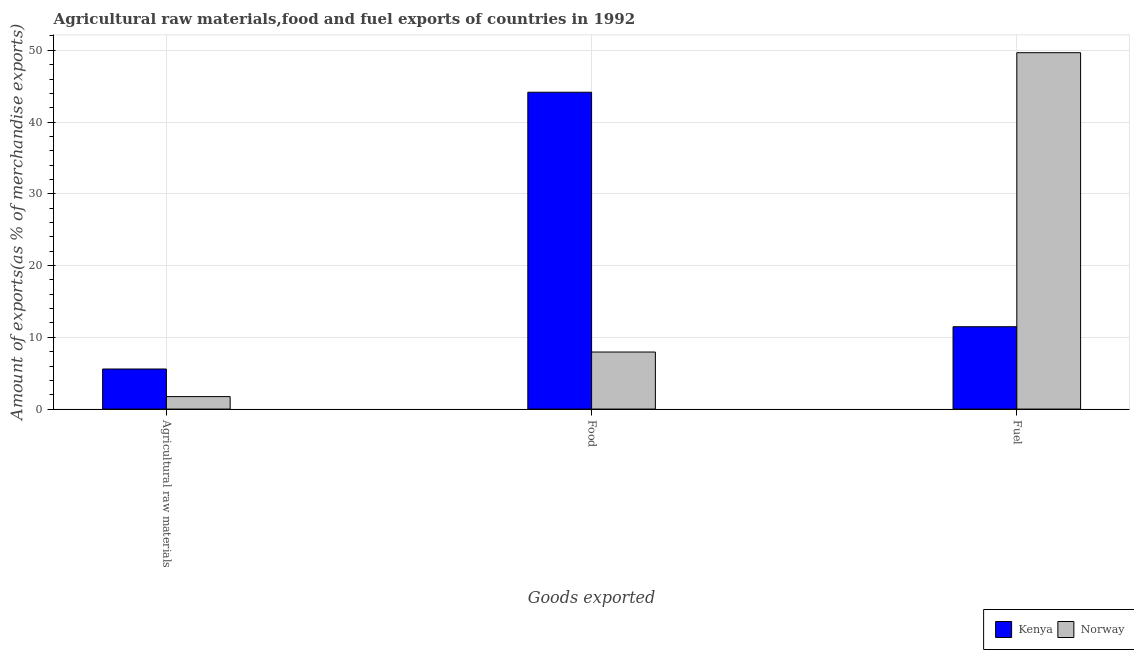How many different coloured bars are there?
Give a very brief answer. 2. How many groups of bars are there?
Make the answer very short. 3. Are the number of bars per tick equal to the number of legend labels?
Your answer should be very brief. Yes. What is the label of the 2nd group of bars from the left?
Make the answer very short. Food. What is the percentage of fuel exports in Norway?
Your answer should be very brief. 49.67. Across all countries, what is the maximum percentage of fuel exports?
Offer a terse response. 49.67. Across all countries, what is the minimum percentage of fuel exports?
Keep it short and to the point. 11.48. In which country was the percentage of food exports maximum?
Provide a short and direct response. Kenya. In which country was the percentage of fuel exports minimum?
Make the answer very short. Kenya. What is the total percentage of raw materials exports in the graph?
Offer a terse response. 7.32. What is the difference between the percentage of food exports in Norway and that in Kenya?
Offer a very short reply. -36.2. What is the difference between the percentage of fuel exports in Norway and the percentage of food exports in Kenya?
Keep it short and to the point. 5.51. What is the average percentage of raw materials exports per country?
Your answer should be very brief. 3.66. What is the difference between the percentage of food exports and percentage of fuel exports in Kenya?
Your response must be concise. 32.68. In how many countries, is the percentage of fuel exports greater than 38 %?
Keep it short and to the point. 1. What is the ratio of the percentage of food exports in Norway to that in Kenya?
Offer a terse response. 0.18. Is the difference between the percentage of fuel exports in Kenya and Norway greater than the difference between the percentage of food exports in Kenya and Norway?
Provide a succinct answer. No. What is the difference between the highest and the second highest percentage of raw materials exports?
Offer a terse response. 3.85. What is the difference between the highest and the lowest percentage of raw materials exports?
Give a very brief answer. 3.85. In how many countries, is the percentage of raw materials exports greater than the average percentage of raw materials exports taken over all countries?
Your answer should be compact. 1. Is the sum of the percentage of fuel exports in Norway and Kenya greater than the maximum percentage of food exports across all countries?
Offer a terse response. Yes. What does the 2nd bar from the right in Agricultural raw materials represents?
Your answer should be very brief. Kenya. Is it the case that in every country, the sum of the percentage of raw materials exports and percentage of food exports is greater than the percentage of fuel exports?
Make the answer very short. No. Are all the bars in the graph horizontal?
Keep it short and to the point. No. Are the values on the major ticks of Y-axis written in scientific E-notation?
Your answer should be compact. No. Does the graph contain any zero values?
Offer a very short reply. No. How are the legend labels stacked?
Your answer should be very brief. Horizontal. What is the title of the graph?
Offer a terse response. Agricultural raw materials,food and fuel exports of countries in 1992. Does "Korea (Democratic)" appear as one of the legend labels in the graph?
Provide a succinct answer. No. What is the label or title of the X-axis?
Keep it short and to the point. Goods exported. What is the label or title of the Y-axis?
Your answer should be very brief. Amount of exports(as % of merchandise exports). What is the Amount of exports(as % of merchandise exports) in Kenya in Agricultural raw materials?
Offer a very short reply. 5.59. What is the Amount of exports(as % of merchandise exports) in Norway in Agricultural raw materials?
Offer a very short reply. 1.74. What is the Amount of exports(as % of merchandise exports) in Kenya in Food?
Provide a short and direct response. 44.16. What is the Amount of exports(as % of merchandise exports) of Norway in Food?
Your answer should be very brief. 7.95. What is the Amount of exports(as % of merchandise exports) in Kenya in Fuel?
Your answer should be very brief. 11.48. What is the Amount of exports(as % of merchandise exports) in Norway in Fuel?
Your answer should be compact. 49.67. Across all Goods exported, what is the maximum Amount of exports(as % of merchandise exports) in Kenya?
Make the answer very short. 44.16. Across all Goods exported, what is the maximum Amount of exports(as % of merchandise exports) in Norway?
Provide a short and direct response. 49.67. Across all Goods exported, what is the minimum Amount of exports(as % of merchandise exports) in Kenya?
Ensure brevity in your answer.  5.59. Across all Goods exported, what is the minimum Amount of exports(as % of merchandise exports) of Norway?
Your answer should be very brief. 1.74. What is the total Amount of exports(as % of merchandise exports) in Kenya in the graph?
Keep it short and to the point. 61.22. What is the total Amount of exports(as % of merchandise exports) in Norway in the graph?
Give a very brief answer. 59.36. What is the difference between the Amount of exports(as % of merchandise exports) in Kenya in Agricultural raw materials and that in Food?
Provide a succinct answer. -38.57. What is the difference between the Amount of exports(as % of merchandise exports) in Norway in Agricultural raw materials and that in Food?
Your response must be concise. -6.21. What is the difference between the Amount of exports(as % of merchandise exports) in Kenya in Agricultural raw materials and that in Fuel?
Offer a terse response. -5.89. What is the difference between the Amount of exports(as % of merchandise exports) in Norway in Agricultural raw materials and that in Fuel?
Make the answer very short. -47.93. What is the difference between the Amount of exports(as % of merchandise exports) in Kenya in Food and that in Fuel?
Ensure brevity in your answer.  32.68. What is the difference between the Amount of exports(as % of merchandise exports) of Norway in Food and that in Fuel?
Offer a terse response. -41.72. What is the difference between the Amount of exports(as % of merchandise exports) of Kenya in Agricultural raw materials and the Amount of exports(as % of merchandise exports) of Norway in Food?
Make the answer very short. -2.37. What is the difference between the Amount of exports(as % of merchandise exports) in Kenya in Agricultural raw materials and the Amount of exports(as % of merchandise exports) in Norway in Fuel?
Provide a short and direct response. -44.08. What is the difference between the Amount of exports(as % of merchandise exports) of Kenya in Food and the Amount of exports(as % of merchandise exports) of Norway in Fuel?
Ensure brevity in your answer.  -5.51. What is the average Amount of exports(as % of merchandise exports) in Kenya per Goods exported?
Provide a succinct answer. 20.41. What is the average Amount of exports(as % of merchandise exports) in Norway per Goods exported?
Your response must be concise. 19.79. What is the difference between the Amount of exports(as % of merchandise exports) in Kenya and Amount of exports(as % of merchandise exports) in Norway in Agricultural raw materials?
Make the answer very short. 3.85. What is the difference between the Amount of exports(as % of merchandise exports) in Kenya and Amount of exports(as % of merchandise exports) in Norway in Food?
Provide a succinct answer. 36.2. What is the difference between the Amount of exports(as % of merchandise exports) of Kenya and Amount of exports(as % of merchandise exports) of Norway in Fuel?
Provide a short and direct response. -38.19. What is the ratio of the Amount of exports(as % of merchandise exports) in Kenya in Agricultural raw materials to that in Food?
Provide a short and direct response. 0.13. What is the ratio of the Amount of exports(as % of merchandise exports) of Norway in Agricultural raw materials to that in Food?
Provide a succinct answer. 0.22. What is the ratio of the Amount of exports(as % of merchandise exports) in Kenya in Agricultural raw materials to that in Fuel?
Give a very brief answer. 0.49. What is the ratio of the Amount of exports(as % of merchandise exports) in Norway in Agricultural raw materials to that in Fuel?
Your response must be concise. 0.04. What is the ratio of the Amount of exports(as % of merchandise exports) of Kenya in Food to that in Fuel?
Provide a succinct answer. 3.85. What is the ratio of the Amount of exports(as % of merchandise exports) in Norway in Food to that in Fuel?
Your answer should be very brief. 0.16. What is the difference between the highest and the second highest Amount of exports(as % of merchandise exports) in Kenya?
Provide a succinct answer. 32.68. What is the difference between the highest and the second highest Amount of exports(as % of merchandise exports) of Norway?
Make the answer very short. 41.72. What is the difference between the highest and the lowest Amount of exports(as % of merchandise exports) in Kenya?
Provide a succinct answer. 38.57. What is the difference between the highest and the lowest Amount of exports(as % of merchandise exports) of Norway?
Offer a terse response. 47.93. 